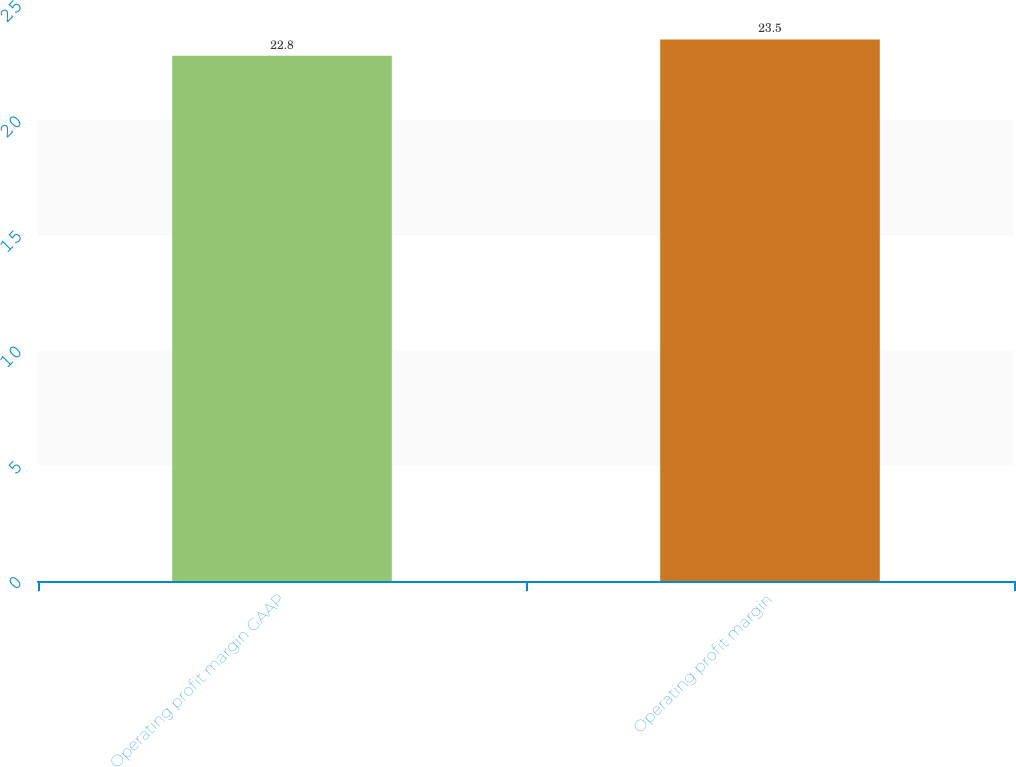Convert chart. <chart><loc_0><loc_0><loc_500><loc_500><bar_chart><fcel>Operating profit margin GAAP<fcel>Operating profit margin<nl><fcel>22.8<fcel>23.5<nl></chart> 